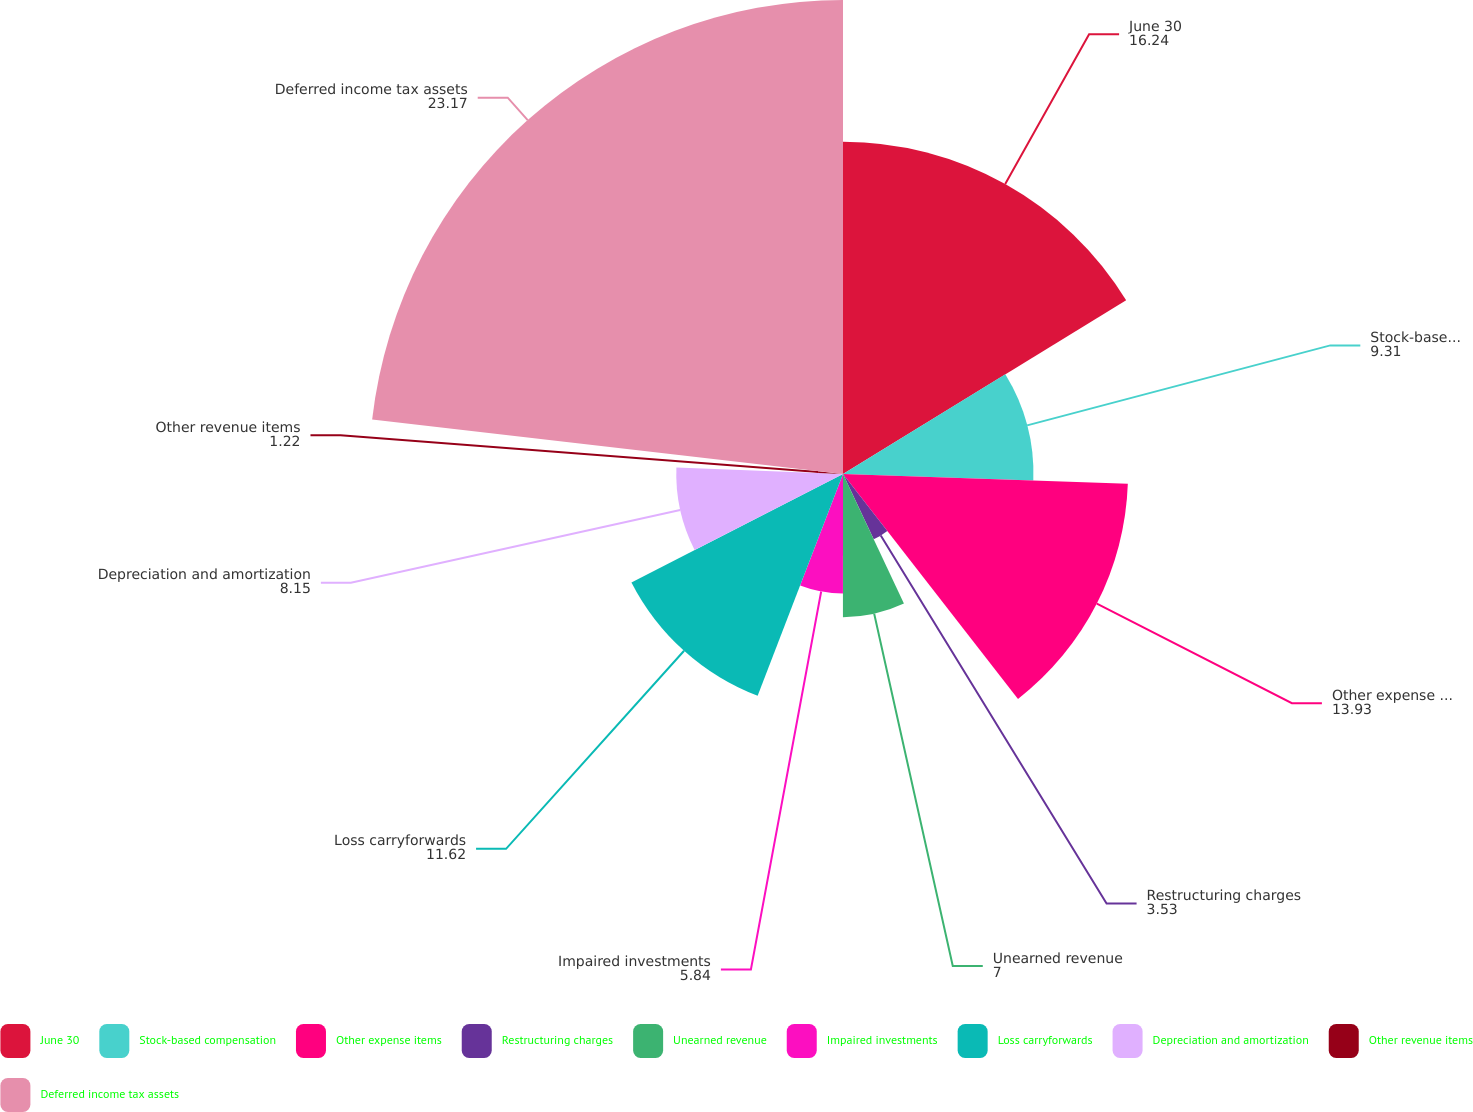Convert chart. <chart><loc_0><loc_0><loc_500><loc_500><pie_chart><fcel>June 30<fcel>Stock-based compensation<fcel>Other expense items<fcel>Restructuring charges<fcel>Unearned revenue<fcel>Impaired investments<fcel>Loss carryforwards<fcel>Depreciation and amortization<fcel>Other revenue items<fcel>Deferred income tax assets<nl><fcel>16.24%<fcel>9.31%<fcel>13.93%<fcel>3.53%<fcel>7.0%<fcel>5.84%<fcel>11.62%<fcel>8.15%<fcel>1.22%<fcel>23.17%<nl></chart> 